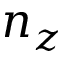<formula> <loc_0><loc_0><loc_500><loc_500>n _ { z }</formula> 